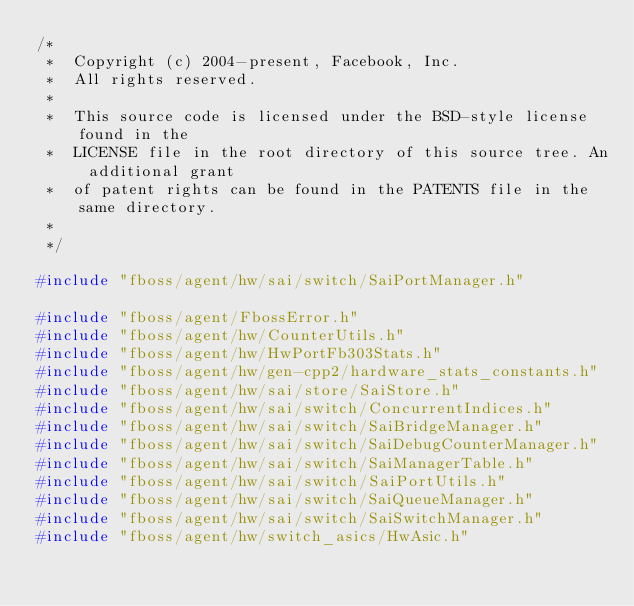Convert code to text. <code><loc_0><loc_0><loc_500><loc_500><_C++_>/*
 *  Copyright (c) 2004-present, Facebook, Inc.
 *  All rights reserved.
 *
 *  This source code is licensed under the BSD-style license found in the
 *  LICENSE file in the root directory of this source tree. An additional grant
 *  of patent rights can be found in the PATENTS file in the same directory.
 *
 */

#include "fboss/agent/hw/sai/switch/SaiPortManager.h"

#include "fboss/agent/FbossError.h"
#include "fboss/agent/hw/CounterUtils.h"
#include "fboss/agent/hw/HwPortFb303Stats.h"
#include "fboss/agent/hw/gen-cpp2/hardware_stats_constants.h"
#include "fboss/agent/hw/sai/store/SaiStore.h"
#include "fboss/agent/hw/sai/switch/ConcurrentIndices.h"
#include "fboss/agent/hw/sai/switch/SaiBridgeManager.h"
#include "fboss/agent/hw/sai/switch/SaiDebugCounterManager.h"
#include "fboss/agent/hw/sai/switch/SaiManagerTable.h"
#include "fboss/agent/hw/sai/switch/SaiPortUtils.h"
#include "fboss/agent/hw/sai/switch/SaiQueueManager.h"
#include "fboss/agent/hw/sai/switch/SaiSwitchManager.h"
#include "fboss/agent/hw/switch_asics/HwAsic.h"</code> 